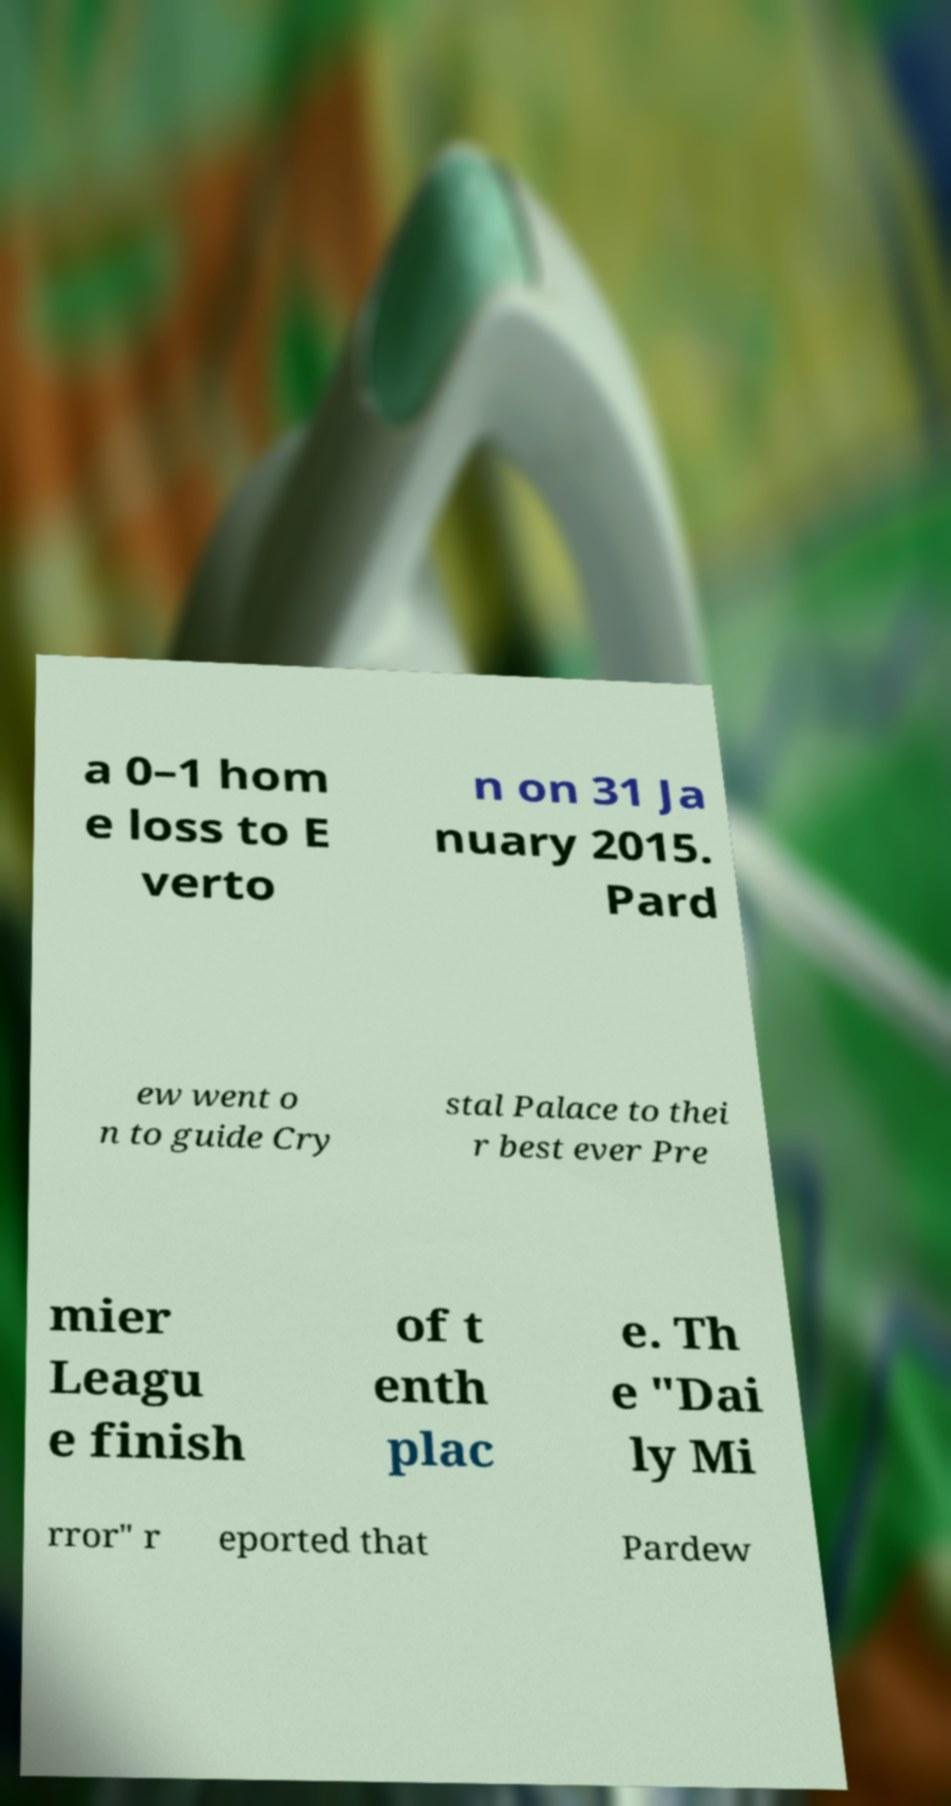There's text embedded in this image that I need extracted. Can you transcribe it verbatim? a 0–1 hom e loss to E verto n on 31 Ja nuary 2015. Pard ew went o n to guide Cry stal Palace to thei r best ever Pre mier Leagu e finish of t enth plac e. Th e "Dai ly Mi rror" r eported that Pardew 